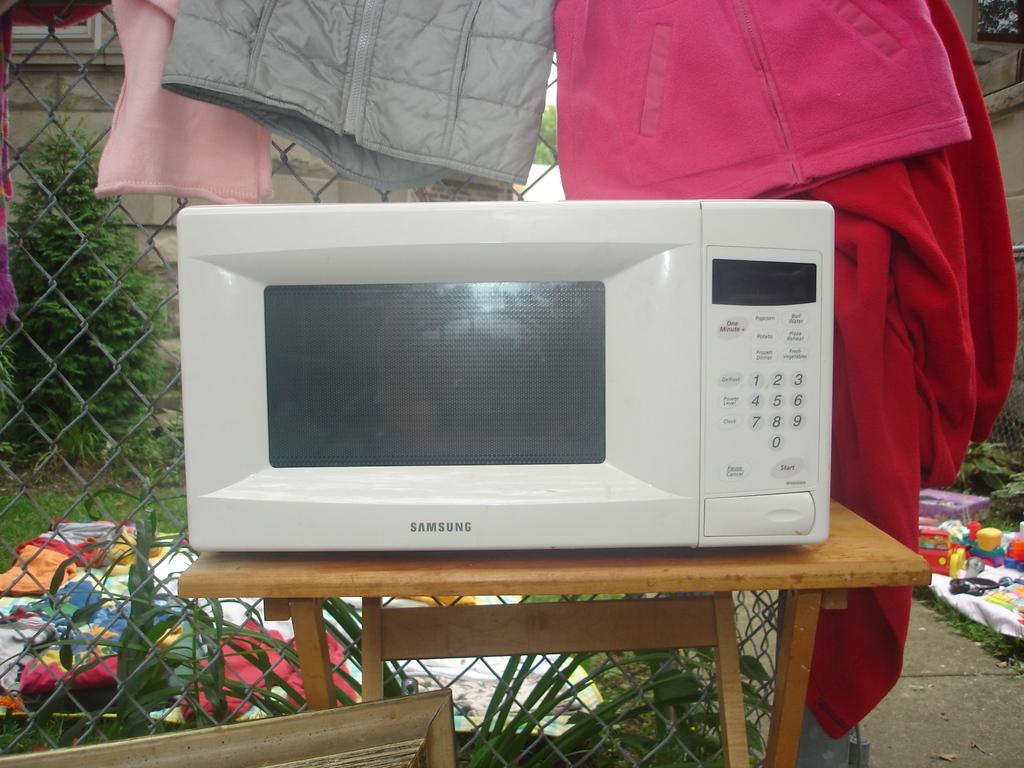What is the name of the company that makes the microwave?
Your answer should be very brief. Samsung. What is the firs number on the pad?
Keep it short and to the point. 1. 